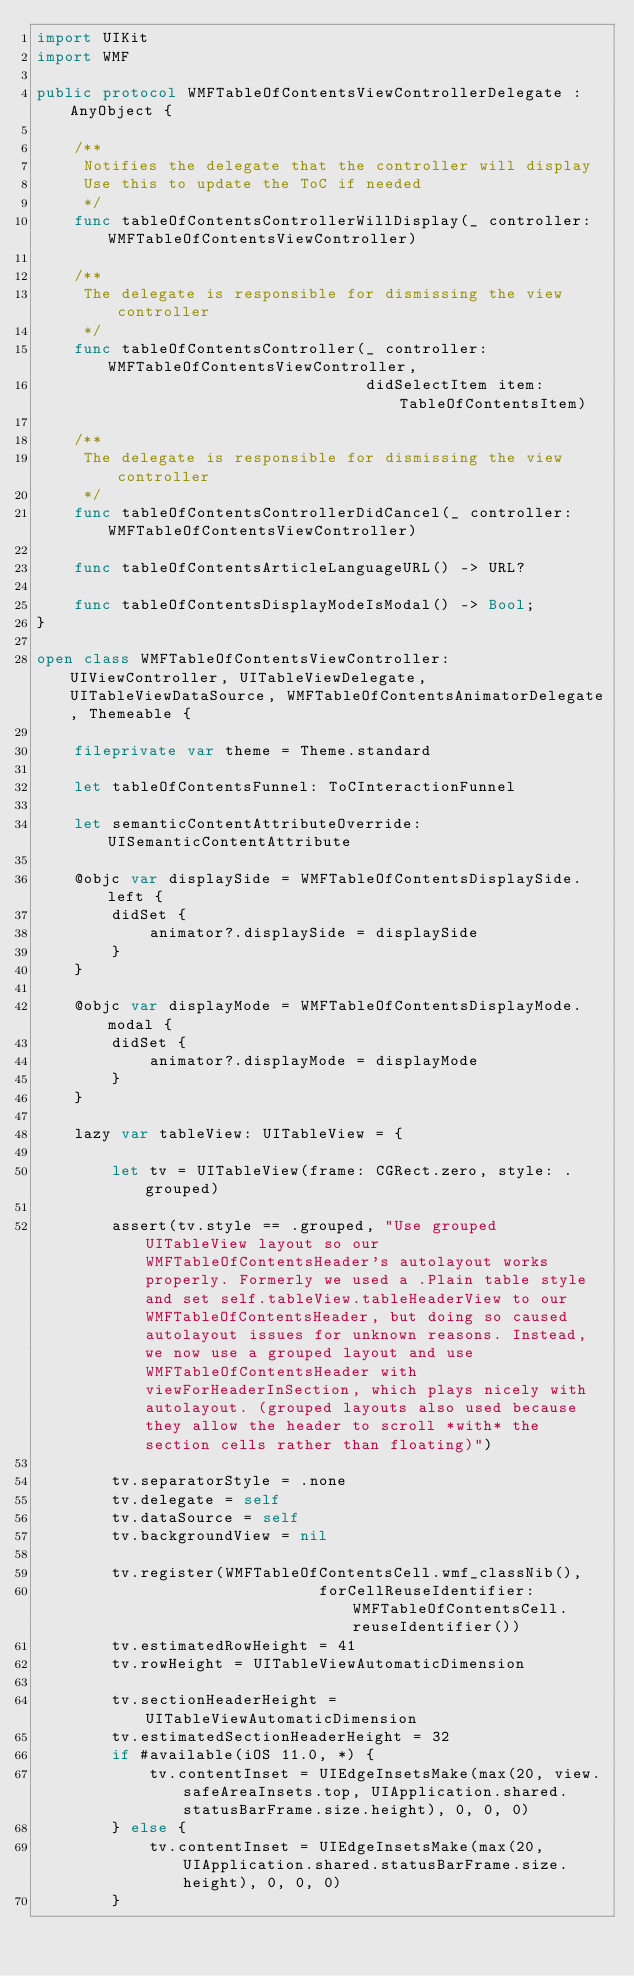Convert code to text. <code><loc_0><loc_0><loc_500><loc_500><_Swift_>import UIKit
import WMF

public protocol WMFTableOfContentsViewControllerDelegate : AnyObject {

    /**
     Notifies the delegate that the controller will display
     Use this to update the ToC if needed
     */
    func tableOfContentsControllerWillDisplay(_ controller: WMFTableOfContentsViewController)

    /**
     The delegate is responsible for dismissing the view controller
     */
    func tableOfContentsController(_ controller: WMFTableOfContentsViewController,
                                   didSelectItem item: TableOfContentsItem)

    /**
     The delegate is responsible for dismissing the view controller
     */
    func tableOfContentsControllerDidCancel(_ controller: WMFTableOfContentsViewController)

    func tableOfContentsArticleLanguageURL() -> URL?
    
    func tableOfContentsDisplayModeIsModal() -> Bool;
}

open class WMFTableOfContentsViewController: UIViewController, UITableViewDelegate, UITableViewDataSource, WMFTableOfContentsAnimatorDelegate, Themeable {
    
    fileprivate var theme = Theme.standard
    
    let tableOfContentsFunnel: ToCInteractionFunnel

    let semanticContentAttributeOverride: UISemanticContentAttribute
    
    @objc var displaySide = WMFTableOfContentsDisplaySide.left {
        didSet {
            animator?.displaySide = displaySide
        }
    }
    
    @objc var displayMode = WMFTableOfContentsDisplayMode.modal {
        didSet {
            animator?.displayMode = displayMode
        }
    }

    lazy var tableView: UITableView = {
        
        let tv = UITableView(frame: CGRect.zero, style: .grouped)
        
        assert(tv.style == .grouped, "Use grouped UITableView layout so our WMFTableOfContentsHeader's autolayout works properly. Formerly we used a .Plain table style and set self.tableView.tableHeaderView to our WMFTableOfContentsHeader, but doing so caused autolayout issues for unknown reasons. Instead, we now use a grouped layout and use WMFTableOfContentsHeader with viewForHeaderInSection, which plays nicely with autolayout. (grouped layouts also used because they allow the header to scroll *with* the section cells rather than floating)")
        
        tv.separatorStyle = .none
        tv.delegate = self
        tv.dataSource = self
        tv.backgroundView = nil

        tv.register(WMFTableOfContentsCell.wmf_classNib(),
                              forCellReuseIdentifier: WMFTableOfContentsCell.reuseIdentifier())
        tv.estimatedRowHeight = 41
        tv.rowHeight = UITableViewAutomaticDimension
        
        tv.sectionHeaderHeight = UITableViewAutomaticDimension
        tv.estimatedSectionHeaderHeight = 32
        if #available(iOS 11.0, *) {
            tv.contentInset = UIEdgeInsetsMake(max(20, view.safeAreaInsets.top, UIApplication.shared.statusBarFrame.size.height), 0, 0, 0)
        } else {
            tv.contentInset = UIEdgeInsetsMake(max(20, UIApplication.shared.statusBarFrame.size.height), 0, 0, 0)
        }</code> 